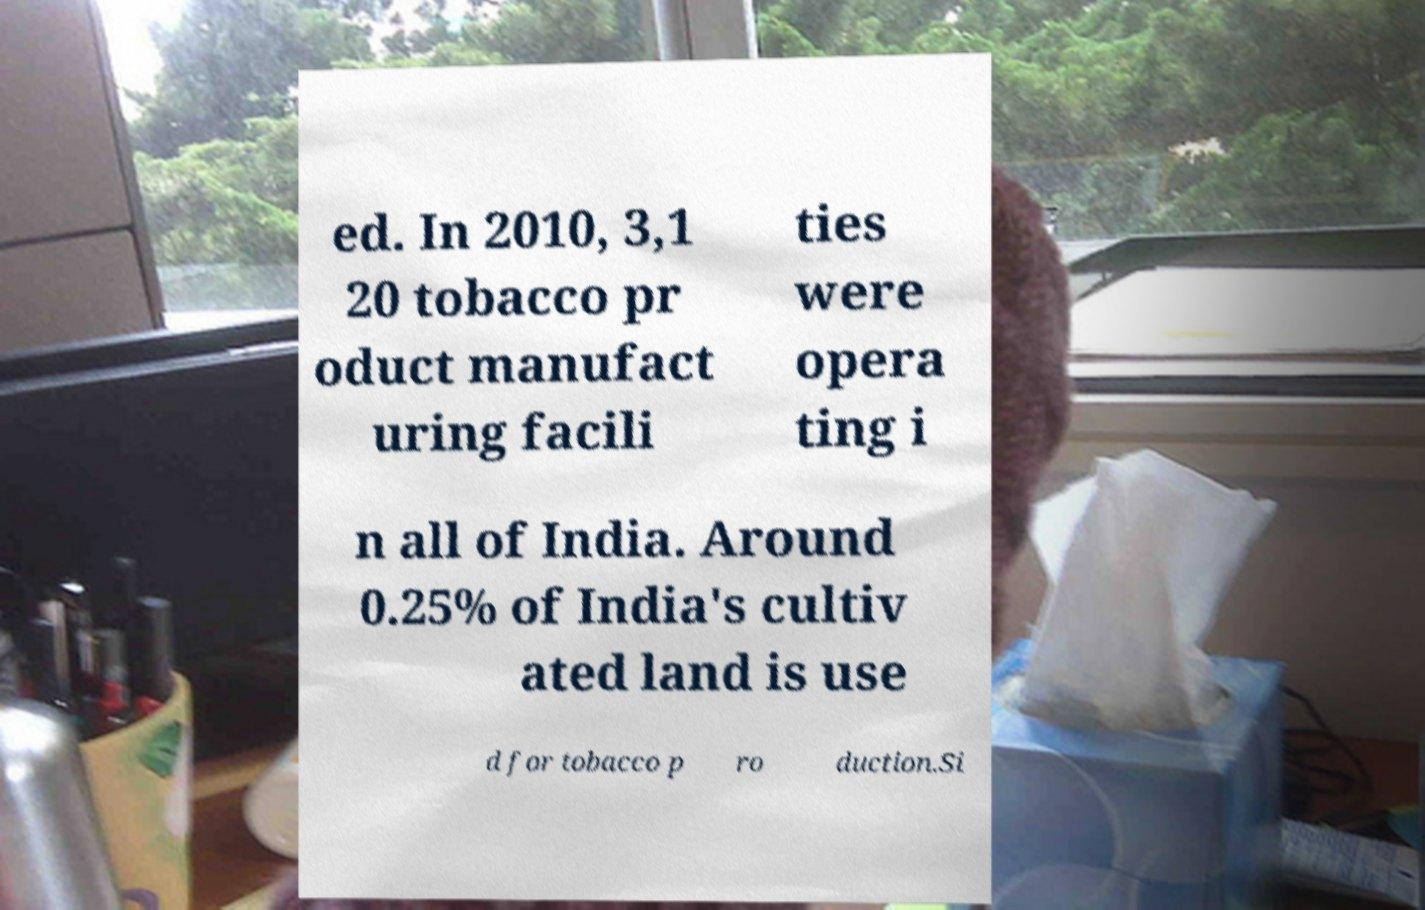For documentation purposes, I need the text within this image transcribed. Could you provide that? ed. In 2010, 3,1 20 tobacco pr oduct manufact uring facili ties were opera ting i n all of India. Around 0.25% of India's cultiv ated land is use d for tobacco p ro duction.Si 